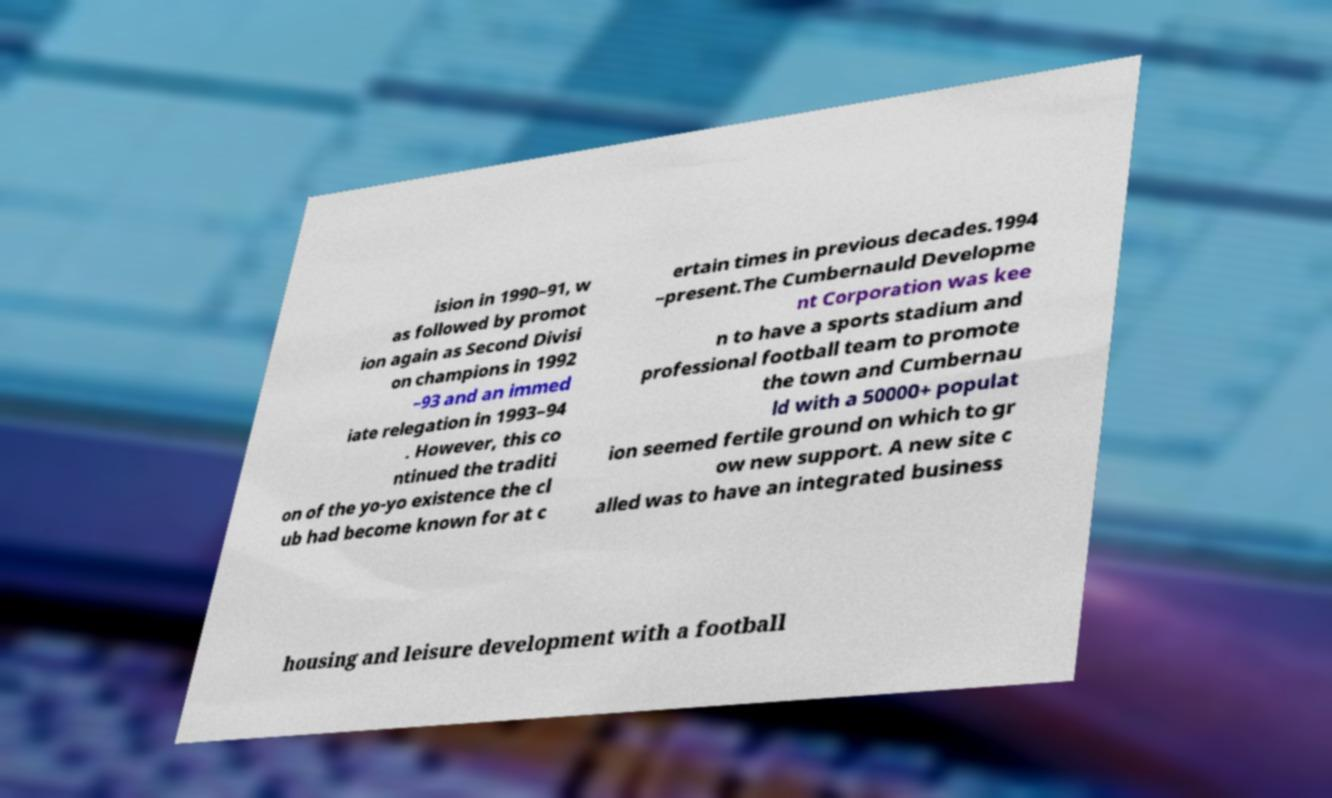Please read and relay the text visible in this image. What does it say? ision in 1990–91, w as followed by promot ion again as Second Divisi on champions in 1992 –93 and an immed iate relegation in 1993–94 . However, this co ntinued the traditi on of the yo-yo existence the cl ub had become known for at c ertain times in previous decades.1994 –present.The Cumbernauld Developme nt Corporation was kee n to have a sports stadium and professional football team to promote the town and Cumbernau ld with a 50000+ populat ion seemed fertile ground on which to gr ow new support. A new site c alled was to have an integrated business housing and leisure development with a football 